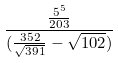<formula> <loc_0><loc_0><loc_500><loc_500>\frac { \frac { 5 ^ { 5 } } { 2 0 3 } } { ( \frac { 3 5 2 } { \sqrt { 3 9 1 } } - \sqrt { 1 0 2 } ) }</formula> 